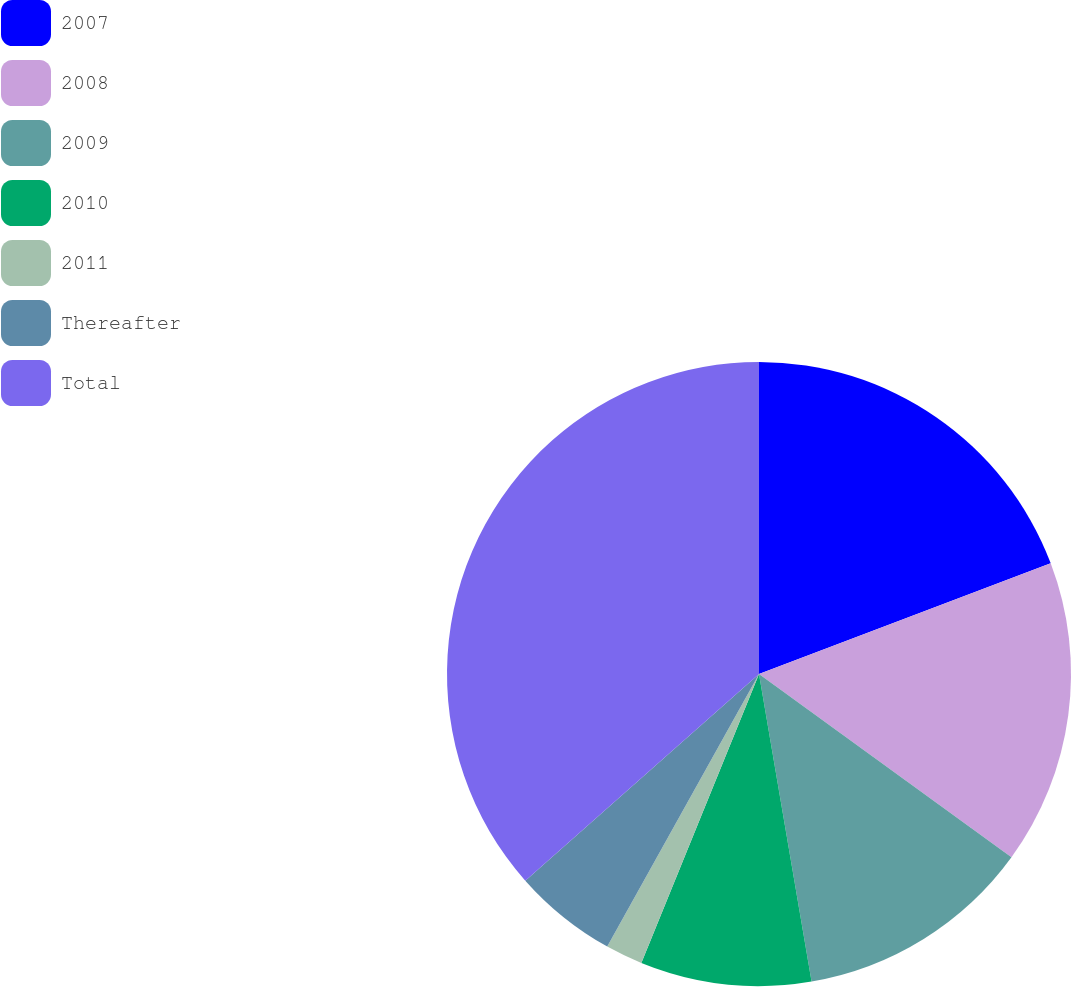Convert chart to OTSL. <chart><loc_0><loc_0><loc_500><loc_500><pie_chart><fcel>2007<fcel>2008<fcel>2009<fcel>2010<fcel>2011<fcel>Thereafter<fcel>Total<nl><fcel>19.23%<fcel>15.77%<fcel>12.31%<fcel>8.85%<fcel>1.93%<fcel>5.39%<fcel>36.53%<nl></chart> 